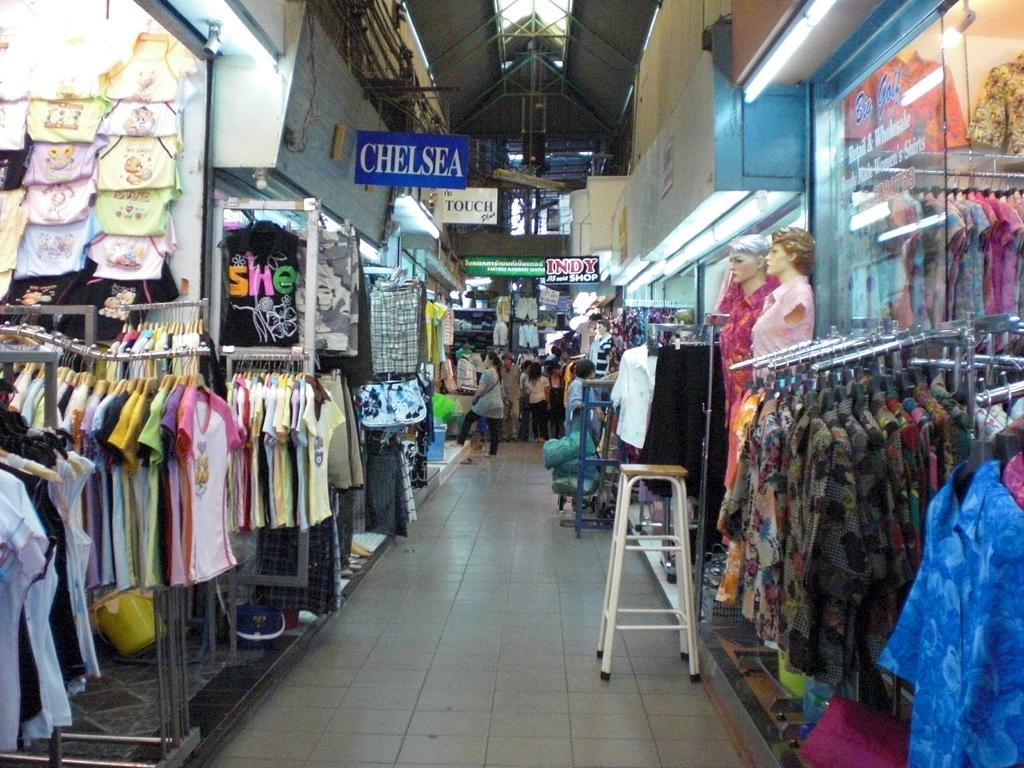<image>
Provide a brief description of the given image. A clothing store aisle that says Chelsea on a hanging sign. 